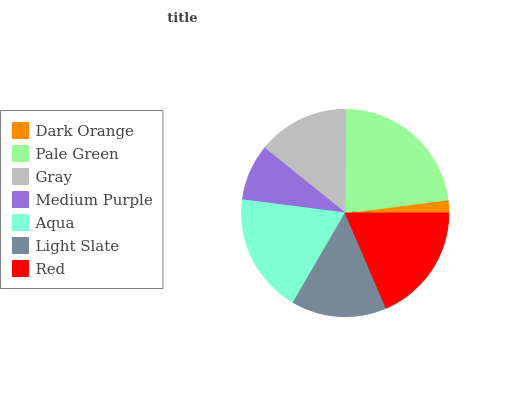Is Dark Orange the minimum?
Answer yes or no. Yes. Is Pale Green the maximum?
Answer yes or no. Yes. Is Gray the minimum?
Answer yes or no. No. Is Gray the maximum?
Answer yes or no. No. Is Pale Green greater than Gray?
Answer yes or no. Yes. Is Gray less than Pale Green?
Answer yes or no. Yes. Is Gray greater than Pale Green?
Answer yes or no. No. Is Pale Green less than Gray?
Answer yes or no. No. Is Light Slate the high median?
Answer yes or no. Yes. Is Light Slate the low median?
Answer yes or no. Yes. Is Dark Orange the high median?
Answer yes or no. No. Is Red the low median?
Answer yes or no. No. 